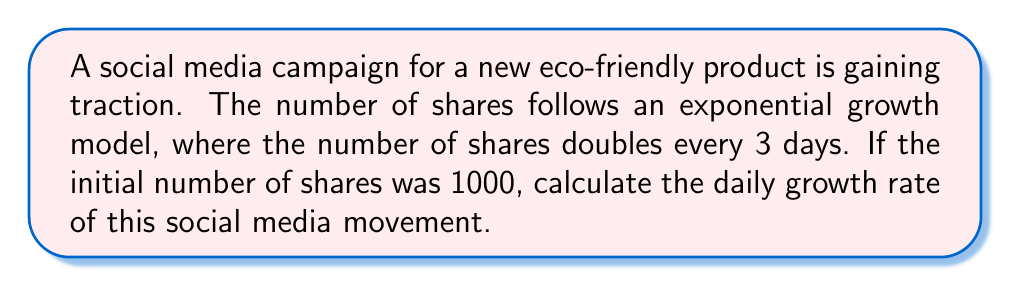Give your solution to this math problem. Let's approach this step-by-step:

1) The general form of exponential growth is:

   $A(t) = A_0 \cdot (1+r)^t$

   Where $A(t)$ is the amount at time $t$, $A_0$ is the initial amount, $r$ is the growth rate, and $t$ is the time.

2) We know that the number of shares doubles every 3 days. This means:

   $2000 = 1000 \cdot (1+r)^3$

3) Dividing both sides by 1000:

   $2 = (1+r)^3$

4) Taking the cube root of both sides:

   $\sqrt[3]{2} = 1+r$

5) Solving for $r$:

   $r = \sqrt[3]{2} - 1$

6) Calculate this value:

   $r \approx 1.2599 - 1 = 0.2599$

7) This is the growth rate over 3 days. To get the daily rate, we divide by 3:

   $r_{daily} = \frac{0.2599}{3} \approx 0.0866$

8) Convert to a percentage:

   $0.0866 \times 100\% = 8.66\%$
Answer: 8.66% per day 